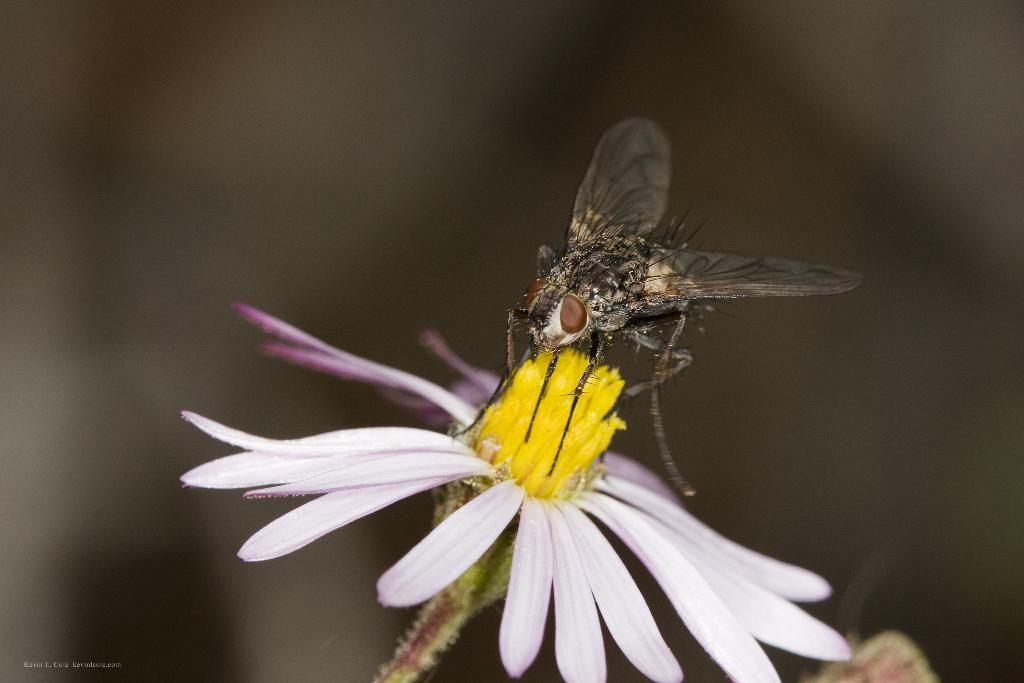What is the main subject of the image? There is a housefly in the image. Where is the housefly located? The housefly is on a flower. Is there any text present in the image? Yes, there is text in the bottom left corner of the image. How would you describe the background of the image? The background of the image is blurry. How does the volcano erupt in the image? There is no volcano present in the image, so it cannot erupt. What is the housefly thinking while sitting on the flower in the image? We cannot determine the thoughts of the housefly from the image, as it is not possible to know what an insect is thinking. 